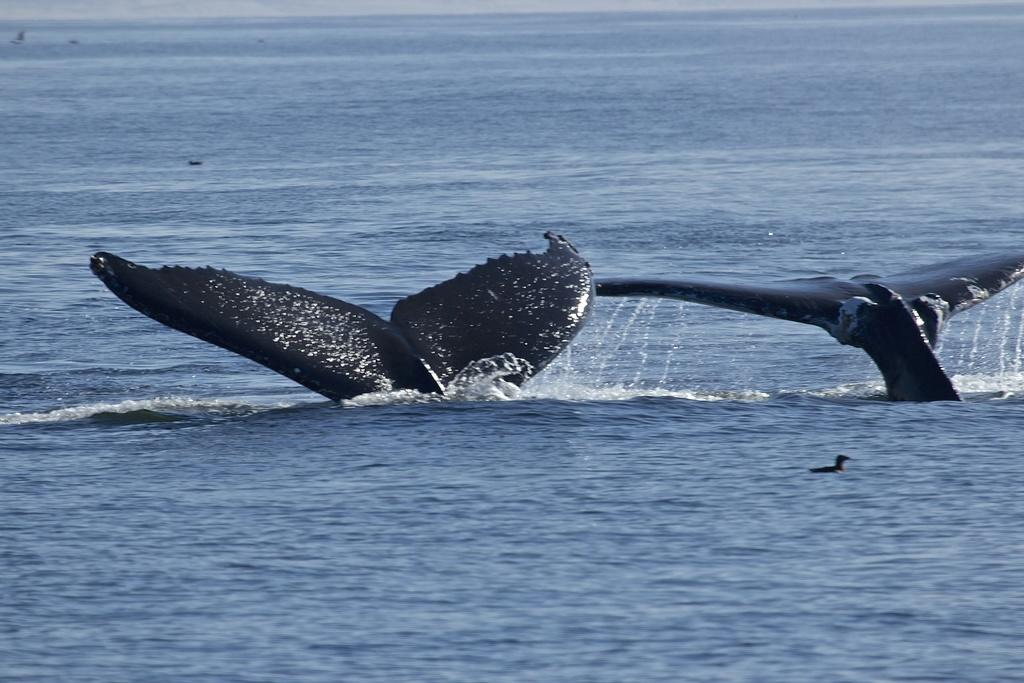What animals can be seen in the water in the image? There are two dolphins in the water in the image. What other type of animal can be seen in the image? There is a bird in the image. What type of men can be seen interacting with the dolphins in the image? There are no men present in the image; it only features dolphins in the water and a bird. What type of liquid can be seen in the image? There is no specific liquid mentioned in the provided facts, and the image only shows dolphins in the water and a bird. What type of cable can be seen connecting the bird to the dolphins in the image? There is no cable present in the image; it only features dolphins in the water and a bird. 